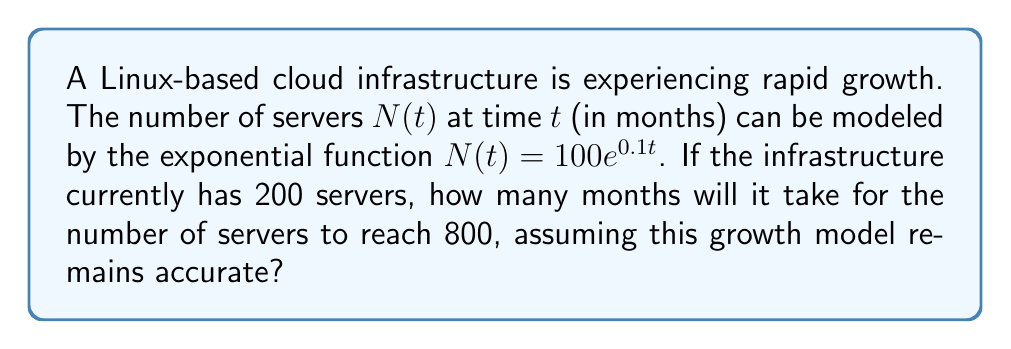Could you help me with this problem? Let's approach this step-by-step:

1) We're given the exponential growth function:
   $N(t) = 100e^{0.1t}$

2) We know that currently, there are 200 servers. Let's call this time $t=0$:
   $200 = 100e^{0.1(0)}$
   $200 = 100$
   This verifies our starting point.

3) We want to find when $N(t) = 800$. So let's set up the equation:
   $800 = 100e^{0.1t}$

4) Divide both sides by 100:
   $8 = e^{0.1t}$

5) Take the natural log of both sides:
   $\ln(8) = \ln(e^{0.1t})$

6) Simplify the right side using the properties of logarithms:
   $\ln(8) = 0.1t$

7) Solve for $t$:
   $t = \frac{\ln(8)}{0.1}$

8) Calculate the result:
   $t = \frac{\ln(8)}{0.1} \approx 20.79$

9) Since we can't have a fractional month in this context, we round up to the nearest whole month.

Therefore, it will take 21 months for the number of servers to reach 800.
Answer: 21 months 